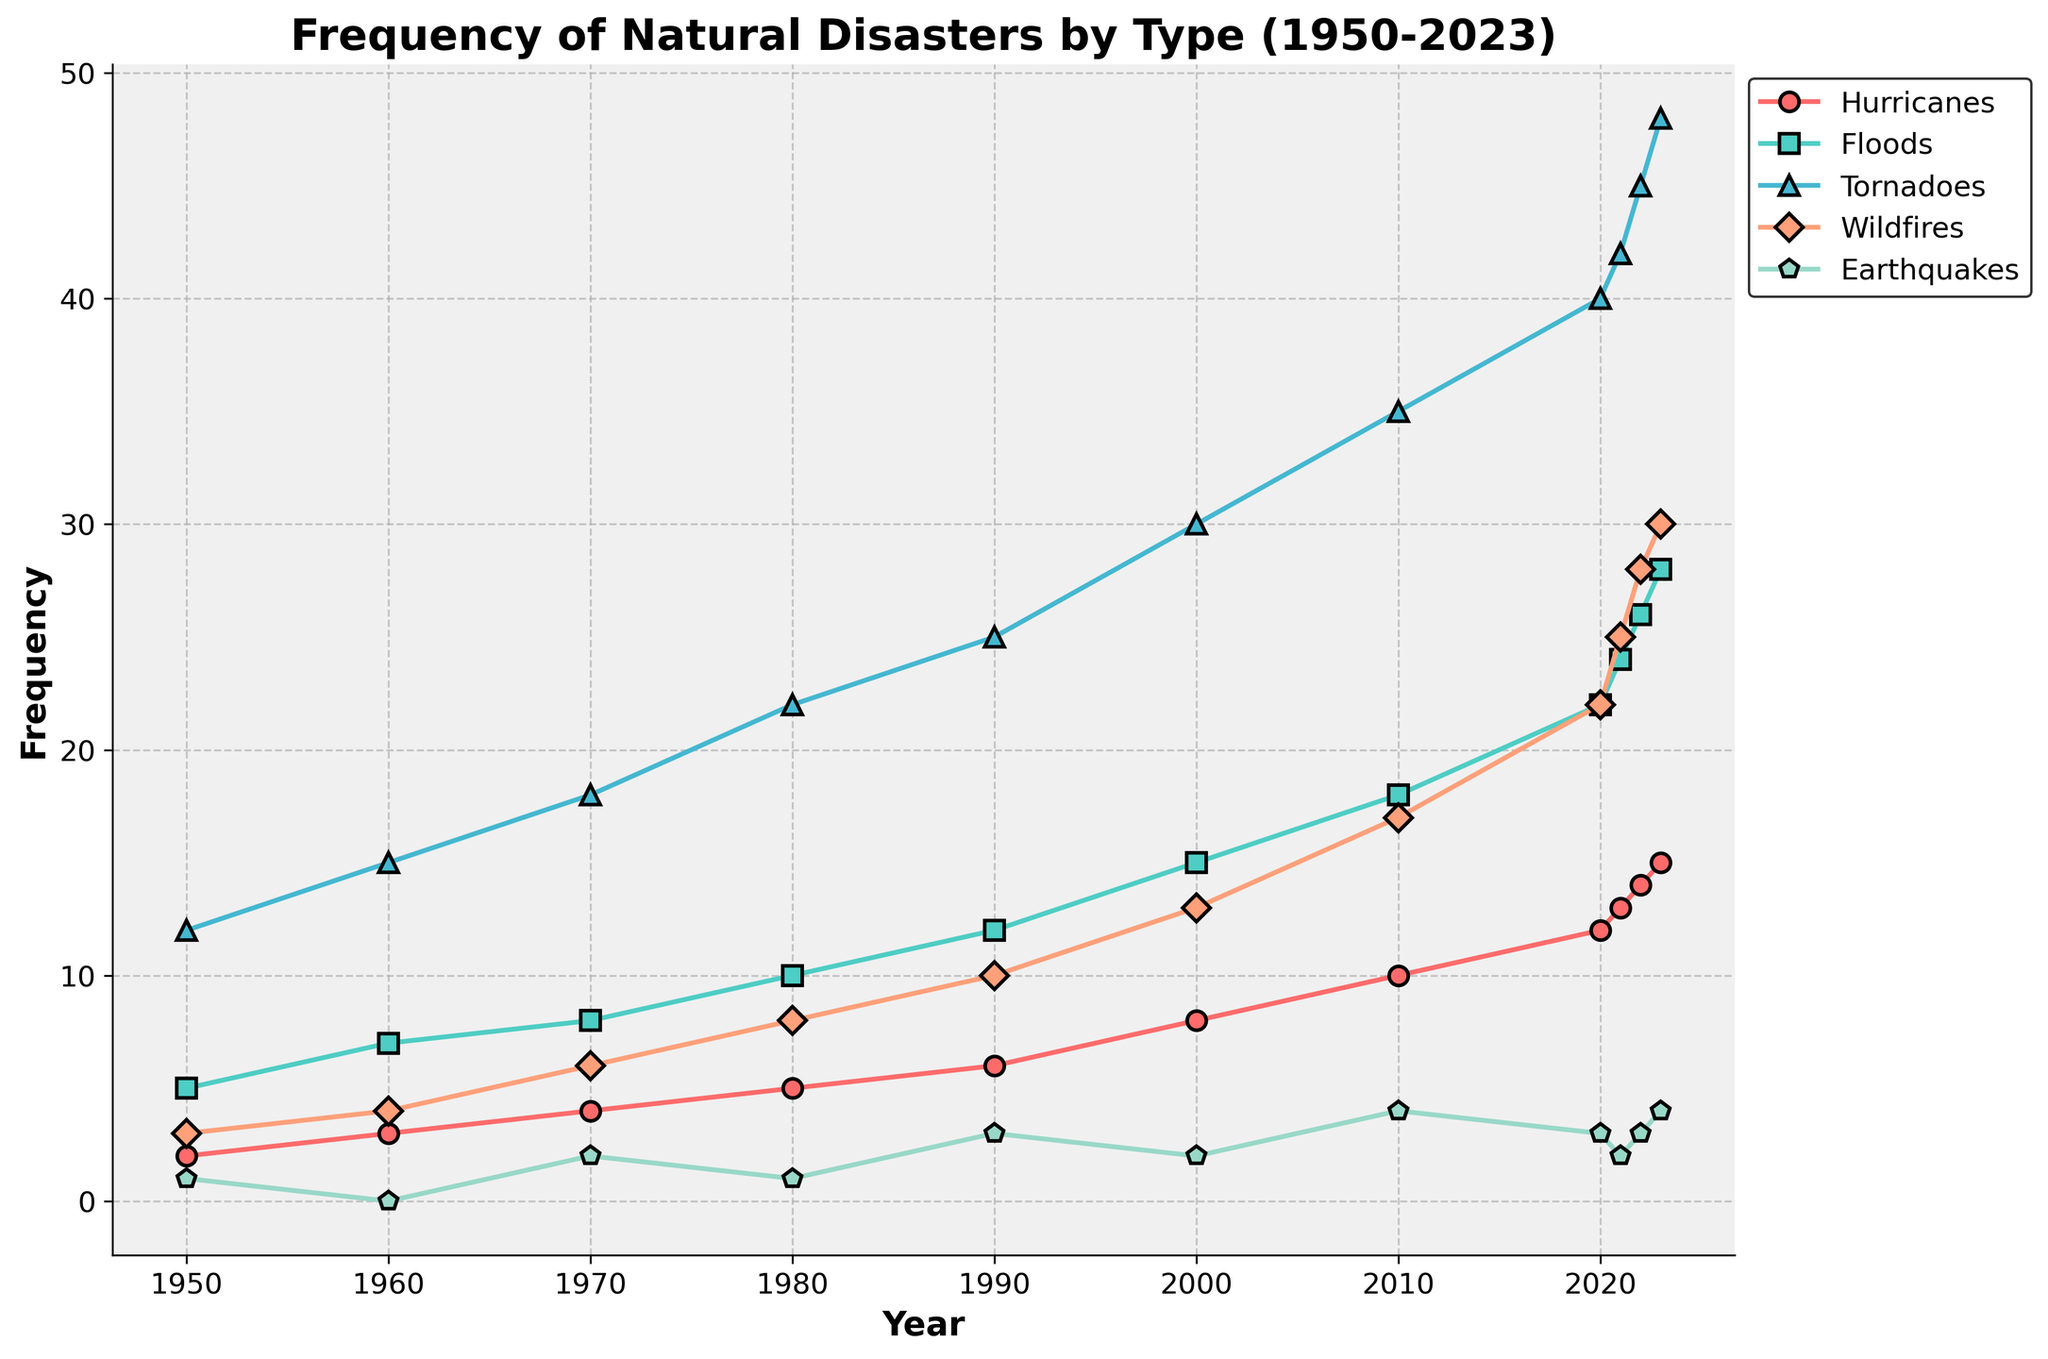What is the overall trend in the frequency of hurricanes from 1950 to 2023? The graph shows the frequency of hurricanes increasing steadily from 1950 (2 hurricanes) to 2023 (15 hurricanes).
Answer: Increasing Which type of natural disaster had the highest frequency in 2023? The graph indicates that tornadoes had the highest frequency in 2023 with 48 occurrences.
Answer: Tornadoes Between wildfires and earthquakes, which had more occurrences in 2000? In 2000, the graph shows that wildfires had 13 occurrences, whereas earthquakes had 2 occurrences.
Answer: Wildfires Which year saw the greatest increase in the frequency of tornadoes? From 1970 to 1980, tornadoes increased from 18 to 22, and the greatest increase occurred from 2010 to 2020, where the frequency went from 35 to 40.
Answer: 2010 to 2020 What is the sum of the frequencies of floods and wildfires in 2023? In 2023, floods occurred 28 times and wildfires 30 times. Their total is 28 + 30 = 58.
Answer: 58 How does the frequency of earthquakes in 1990 compare to that in 2020? In 1990, the frequency of earthquakes was 3, while in 2020, it decreased to 3.
Answer: Decreased What steps could one take to find the average frequency of hurricanes over the years shown in the figure? To find the average frequency of hurricanes, sum the yearly frequencies from 1950 to 2023, which are 2, 3, 4, 5, 6, 8, 10, 12, 13, 14, 15, and then divide by the number of years (74).
Answer: (2+3+4+5+6+8+10+12+13+14+15)/12 = 8.33 Which type of natural disaster shows a more rapid increase in frequency, hurricanes or wildfires, between 2000 and 2023? Hurricanes increased from 8 to 15 (an increase of 7), while wildfires increased from 13 to 30 (an increase of 17). Hence, wildfires show a more rapid increase.
Answer: Wildfires In which decade did the frequency of floods double compared to the previous decade? From 1980 to 1990, the frequency of floods went from 10 to 12, and from 1990 to 2000 it increased from 12 to 15. The decade 1960 to 1970 doubled from 7 to 15.
Answer: 1970 to 1980 Consider the frequency of tornadoes and hurricanes in 2023; are the tornadoes more than three times the frequency of hurricanes? Tornadoes in 2023 are 48, and hurricanes are 15. Three times the frequency of hurricanes is 15 x 3 = 45. Since 48 > 45, tornadoes are indeed more than three times the frequency of hurricanes.
Answer: Yes 